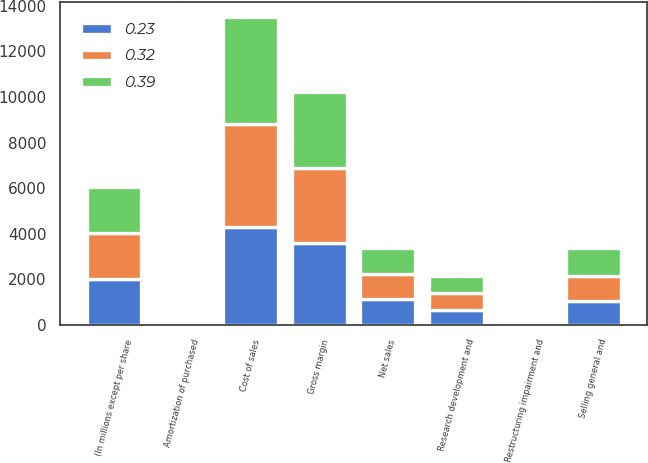<chart> <loc_0><loc_0><loc_500><loc_500><stacked_bar_chart><ecel><fcel>(In millions except per share<fcel>Net sales<fcel>Cost of sales<fcel>Gross margin<fcel>Selling general and<fcel>Research development and<fcel>Amortization of purchased<fcel>Restructuring impairment and<nl><fcel>0.32<fcel>2013<fcel>1126<fcel>4495<fcel>3324<fcel>1126<fcel>710<fcel>31<fcel>67<nl><fcel>0.39<fcel>2012<fcel>1126<fcel>4693<fcel>3319<fcel>1205<fcel>769<fcel>19<fcel>133<nl><fcel>0.23<fcel>2011<fcel>1126<fcel>4314<fcel>3576<fcel>1028<fcel>668<fcel>15<fcel>129<nl></chart> 